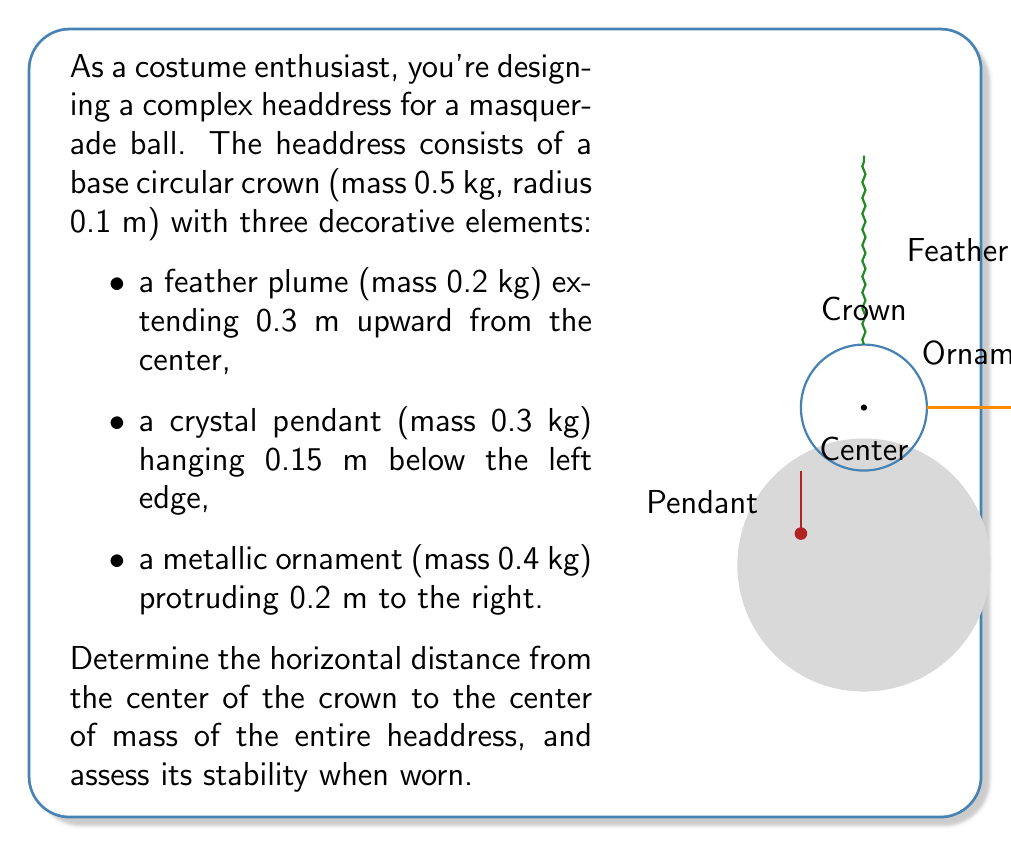Solve this math problem. Let's approach this step-by-step:

1) First, we need to calculate the x-coordinate of the center of mass. We'll use the formula:

   $$x_{CM} = \frac{\sum m_i x_i}{\sum m_i}$$

   where $m_i$ is the mass of each component and $x_i$ is its x-coordinate relative to the center of the crown.

2) Let's assign coordinates to each component:
   - Crown: (0, 0), mass = 0.5 kg
   - Feather: (0, 0), mass = 0.2 kg
   - Pendant: (-0.1, 0), mass = 0.3 kg
   - Ornament: (0.2, 0), mass = 0.4 kg

3) Now, let's calculate the numerator of the formula:

   $$\sum m_i x_i = (0.5 \cdot 0) + (0.2 \cdot 0) + (0.3 \cdot (-0.1)) + (0.4 \cdot 0.2)$$
   $$= -0.03 + 0.08 = 0.05 \text{ kg·m}$$

4) The denominator is the total mass:

   $$\sum m_i = 0.5 + 0.2 + 0.3 + 0.4 = 1.4 \text{ kg}$$

5) Now we can calculate $x_{CM}$:

   $$x_{CM} = \frac{0.05}{1.4} \approx 0.0357 \text{ m} = 3.57 \text{ cm}$$

6) To assess stability, we need to consider:
   a) The center of mass is slightly to the right of the center (3.57 cm).
   b) The head provides a stable base, but the headdress extends significantly above and to the sides.
   c) The pendant on the left somewhat counterbalances the ornament on the right.

   While not perfectly balanced, the small offset of the center of mass suggests reasonable stability. However, sudden movements could cause instability due to the extended decorations.
Answer: $x_{CM} \approx 3.57 \text{ cm}$ to the right; moderately stable but susceptible to sudden movements. 